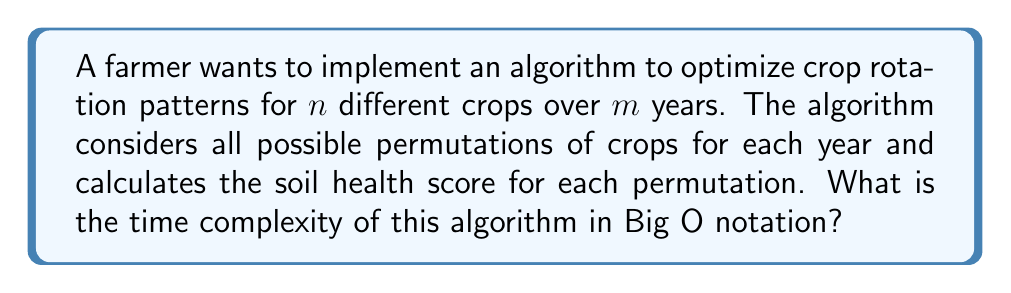Help me with this question. Let's break down the problem and analyze the algorithm step by step:

1. For each year, we need to consider all possible permutations of $n$ crops.
   - The number of permutations for $n$ crops is $n!$

2. We repeat this process for $m$ years.

3. For each permutation in each year, we need to calculate the soil health score. Let's assume this calculation takes constant time, $O(1)$.

4. The total number of operations can be expressed as:

   $$ m \times n! \times O(1) $$

5. In Big O notation, we drop constant factors and focus on the dominant term. In this case, $m$ can be considered a constant factor compared to $n!$, as the number of crops is likely to grow faster than the number of years in practical scenarios.

6. Therefore, the time complexity simplifies to:

   $$ O(n!) $$

This is a factorial time complexity, which is considered highly inefficient for large values of $n$.

It's worth noting that this approach is computationally expensive and may not be practical for a large number of crops. In real-world applications, farmers and agricultural scientists often use heuristic methods or simplified models to make crop rotation decisions more efficiently.
Answer: $O(n!)$ 